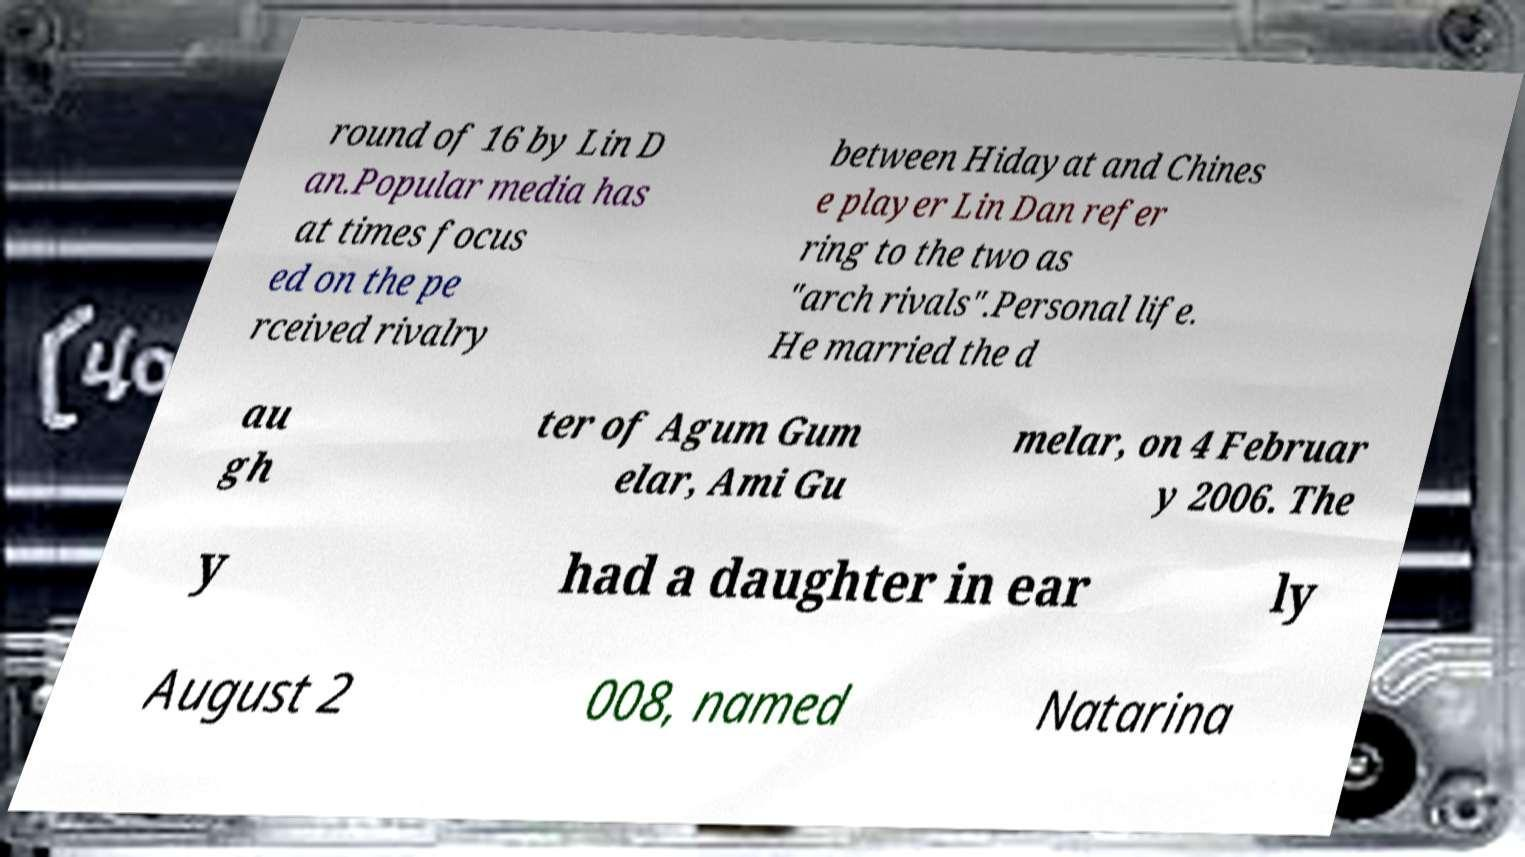Please read and relay the text visible in this image. What does it say? round of 16 by Lin D an.Popular media has at times focus ed on the pe rceived rivalry between Hidayat and Chines e player Lin Dan refer ring to the two as "arch rivals".Personal life. He married the d au gh ter of Agum Gum elar, Ami Gu melar, on 4 Februar y 2006. The y had a daughter in ear ly August 2 008, named Natarina 